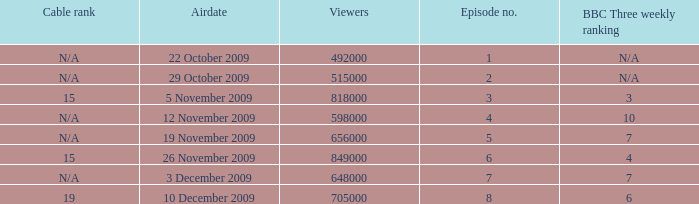How many viewers were there for airdate is 22 october 2009? 492000.0. 